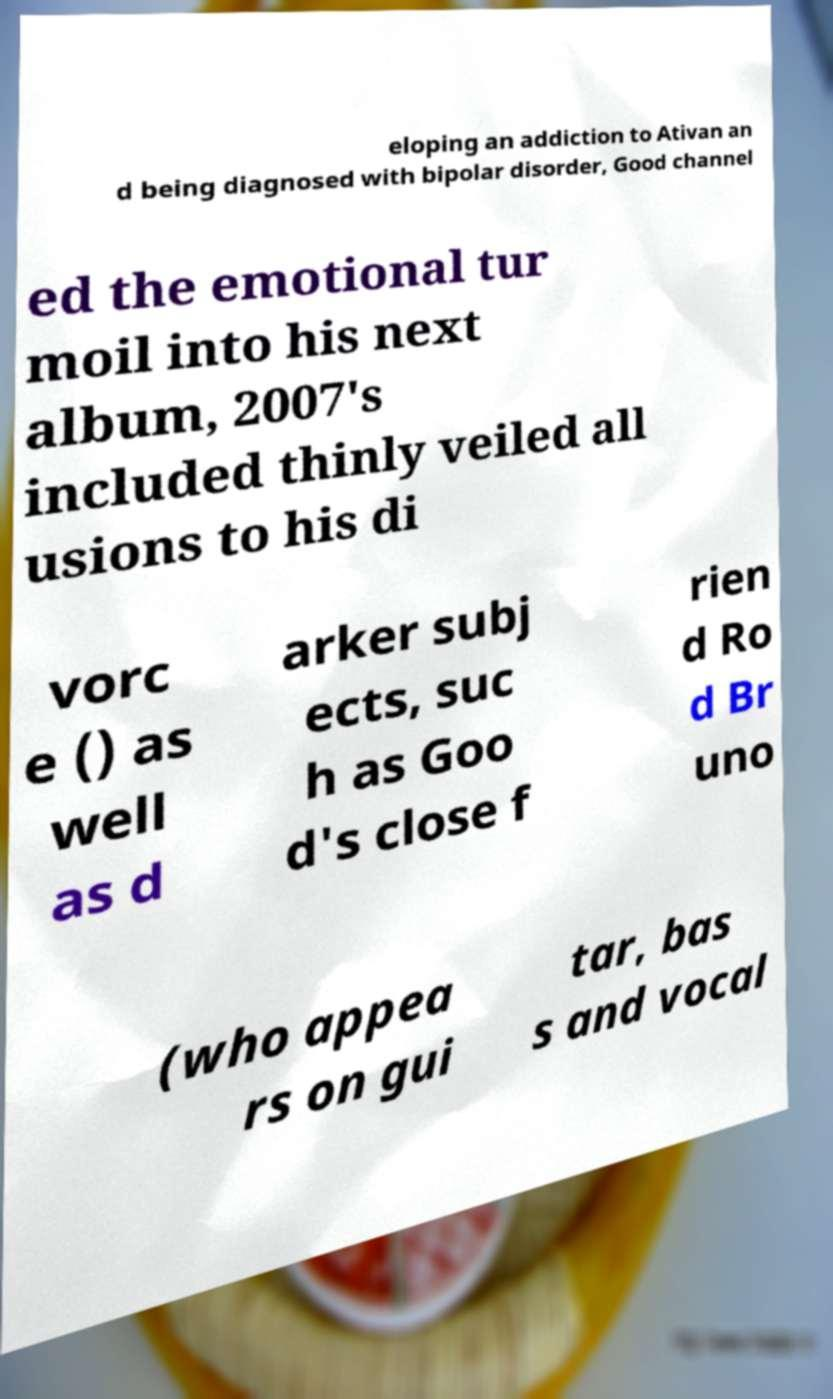Can you read and provide the text displayed in the image?This photo seems to have some interesting text. Can you extract and type it out for me? eloping an addiction to Ativan an d being diagnosed with bipolar disorder, Good channel ed the emotional tur moil into his next album, 2007's included thinly veiled all usions to his di vorc e () as well as d arker subj ects, suc h as Goo d's close f rien d Ro d Br uno (who appea rs on gui tar, bas s and vocal 